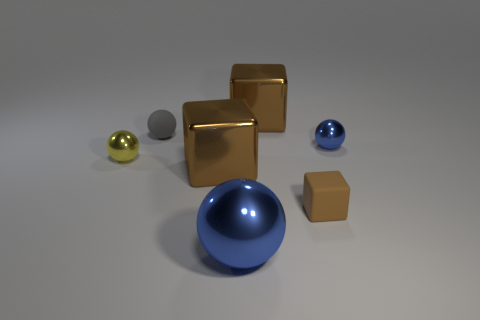Subtract all large metallic balls. How many balls are left? 3 Subtract all yellow balls. How many balls are left? 3 Subtract all purple spheres. Subtract all red cubes. How many spheres are left? 4 Add 3 small brown rubber objects. How many objects exist? 10 Subtract all blocks. How many objects are left? 4 Add 1 tiny yellow cylinders. How many tiny yellow cylinders exist? 1 Subtract 0 green cylinders. How many objects are left? 7 Subtract all purple rubber balls. Subtract all yellow metal objects. How many objects are left? 6 Add 6 tiny gray rubber objects. How many tiny gray rubber objects are left? 7 